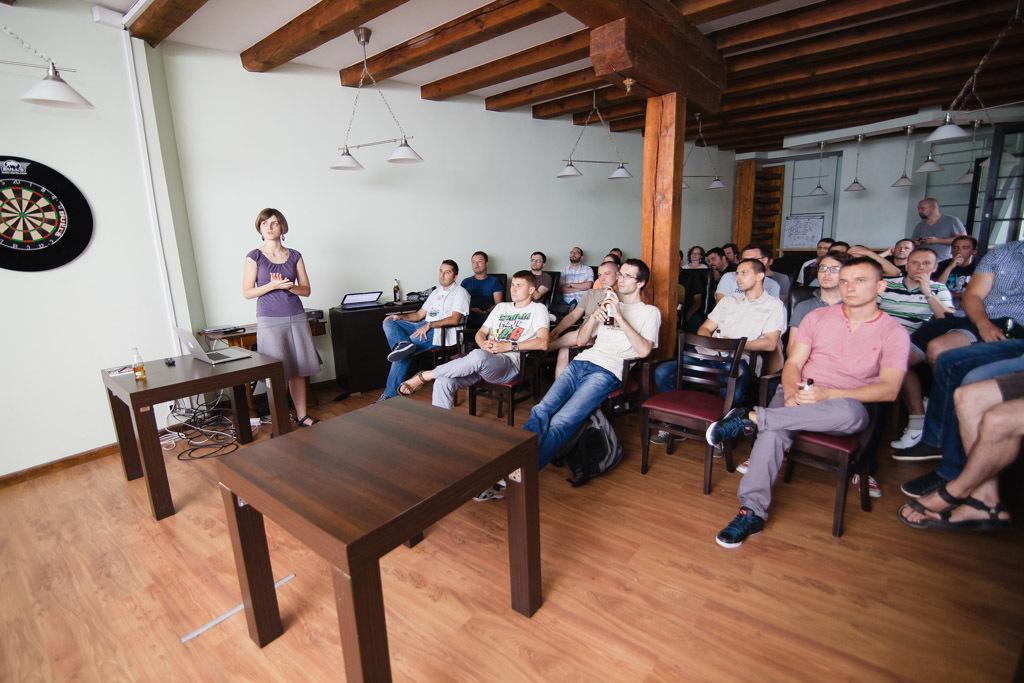Can you describe this image briefly? Here is a woman standing beside there is a table and laptop on the right side people are sitting on the chairs and looking at this side. 